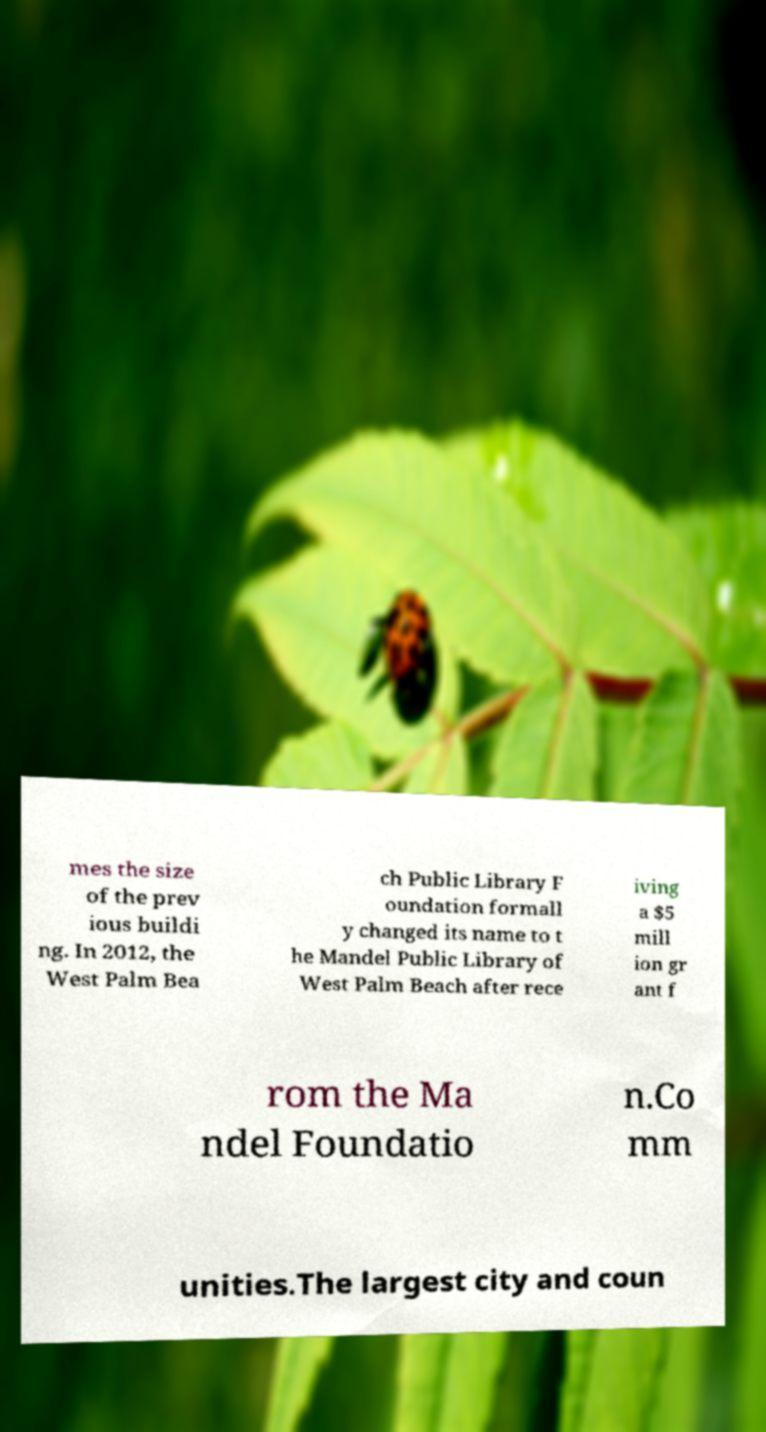For documentation purposes, I need the text within this image transcribed. Could you provide that? mes the size of the prev ious buildi ng. In 2012, the West Palm Bea ch Public Library F oundation formall y changed its name to t he Mandel Public Library of West Palm Beach after rece iving a $5 mill ion gr ant f rom the Ma ndel Foundatio n.Co mm unities.The largest city and coun 